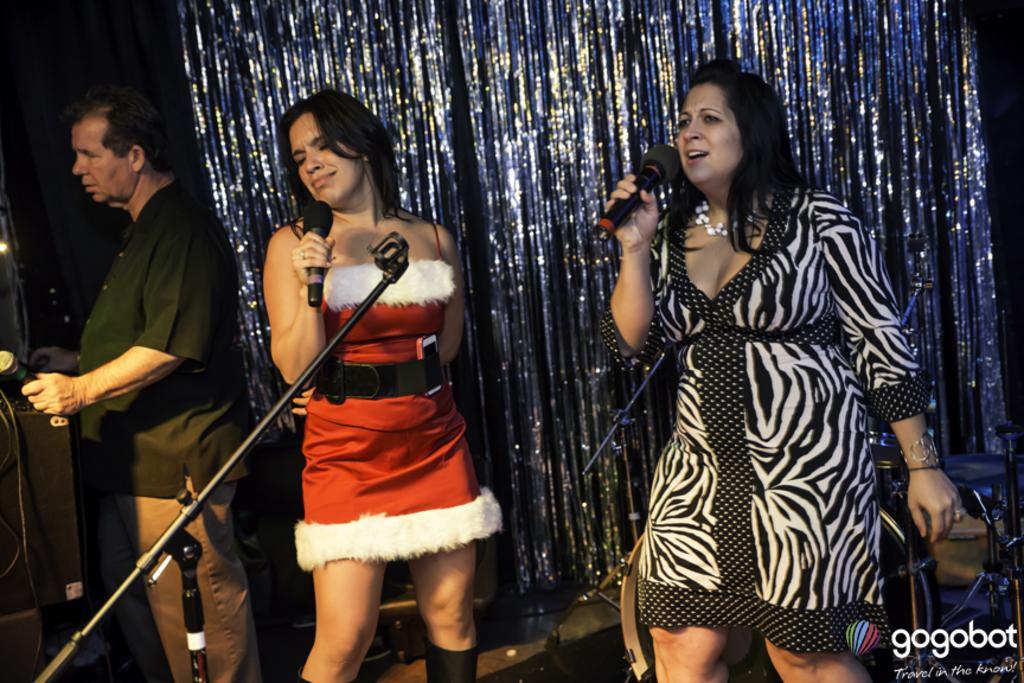Could you give a brief overview of what you see in this image? In this image, we can see people standing and holding mics. In the background, there is a curtain and we can see stands, box and some wires. At the bottom, there is stage and we can see some text. 